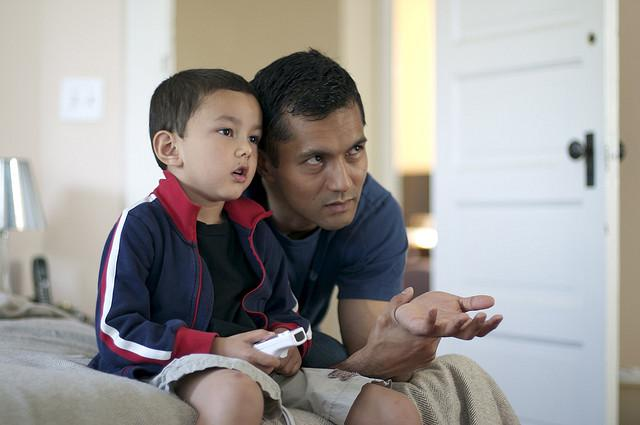What is the man helping the young boy do? Please explain your reasoning. play games. The man is helping the child use a motion controller for a video game. 